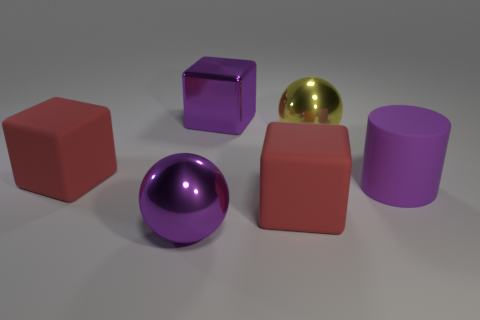Do the big rubber cylinder and the large metal cube have the same color?
Make the answer very short. Yes. The thing on the left side of the shiny object in front of the big yellow shiny object is what shape?
Your answer should be very brief. Cube. What shape is the red object that is in front of the cylinder?
Your answer should be compact. Cube. There is a matte object that is to the right of the big yellow sphere; does it have the same color as the sphere that is left of the metallic block?
Provide a short and direct response. Yes. What number of metallic things are to the left of the purple cube and behind the purple metallic ball?
Give a very brief answer. 0. There is a purple cube that is made of the same material as the large yellow object; what is its size?
Your response must be concise. Large. What size is the cylinder?
Your response must be concise. Large. What is the large purple sphere made of?
Ensure brevity in your answer.  Metal. Does the block that is on the left side of the purple ball have the same size as the purple cube?
Give a very brief answer. Yes. What number of things are purple cylinders or large cubes?
Give a very brief answer. 4. 